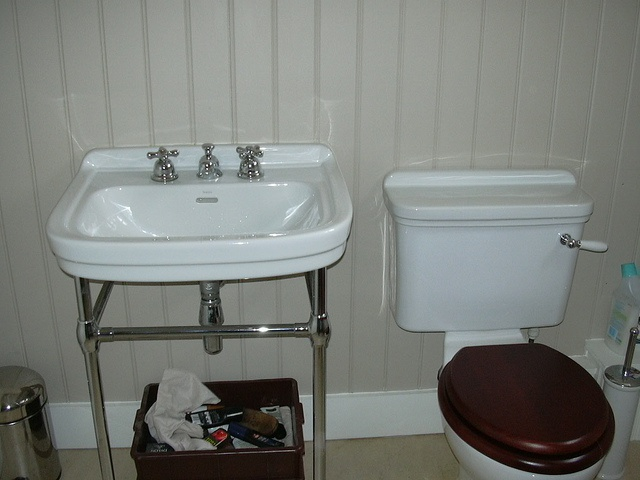Describe the objects in this image and their specific colors. I can see toilet in gray, darkgray, and black tones and sink in gray, darkgray, and lightgray tones in this image. 